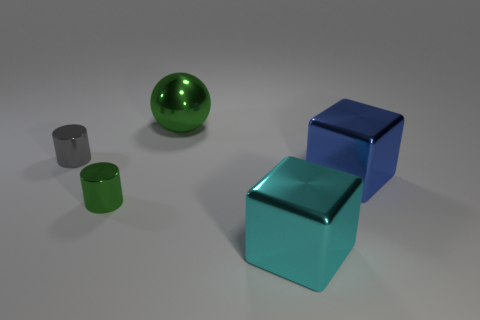Is the big blue object made of the same material as the sphere?
Your answer should be compact. Yes. What number of cylinders are tiny gray things or purple matte things?
Your answer should be compact. 1. What color is the other cube that is made of the same material as the big blue block?
Ensure brevity in your answer.  Cyan. Is the number of blue metallic objects less than the number of large metallic objects?
Keep it short and to the point. Yes. There is a green metallic object that is in front of the large blue object; is it the same shape as the large thing that is to the left of the large cyan object?
Offer a terse response. No. What number of things are either tiny objects or metallic blocks?
Offer a very short reply. 4. There is another cylinder that is the same size as the gray metallic cylinder; what is its color?
Make the answer very short. Green. There is a green metal thing that is to the left of the big green sphere; what number of green metallic objects are on the right side of it?
Provide a succinct answer. 1. What number of metallic objects are on the right side of the large green metallic ball and on the left side of the metal sphere?
Provide a short and direct response. 0. How many things are big metallic things in front of the gray shiny object or big objects in front of the small green metal cylinder?
Offer a terse response. 2. 